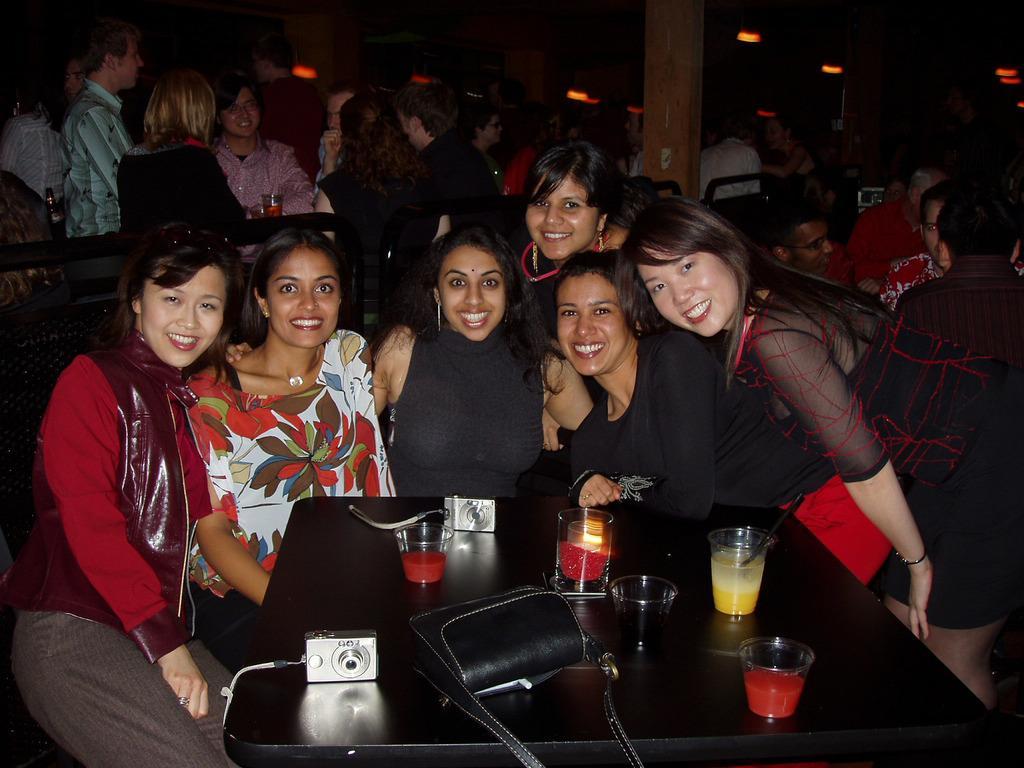Describe this image in one or two sentences. In this image i can see group of women, there are few glasses, camera, bag on the table, at the back ground there are group of people and a pillar. 